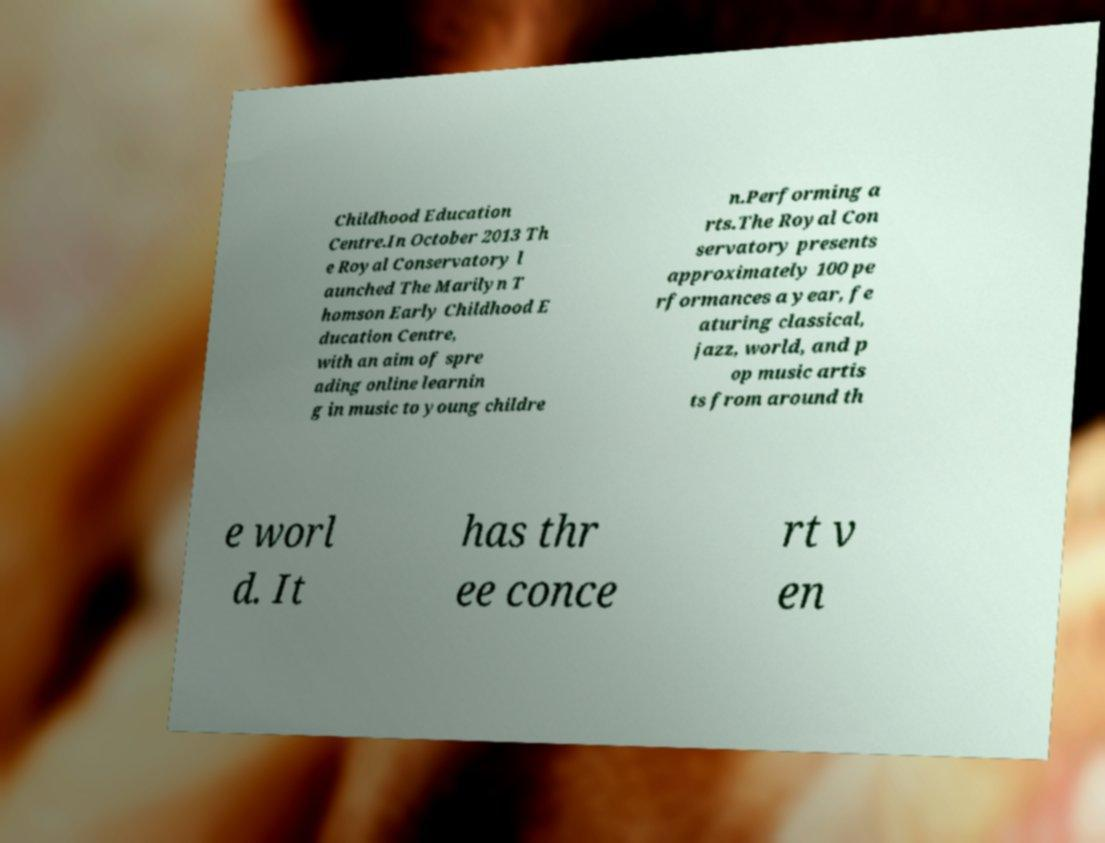There's text embedded in this image that I need extracted. Can you transcribe it verbatim? Childhood Education Centre.In October 2013 Th e Royal Conservatory l aunched The Marilyn T homson Early Childhood E ducation Centre, with an aim of spre ading online learnin g in music to young childre n.Performing a rts.The Royal Con servatory presents approximately 100 pe rformances a year, fe aturing classical, jazz, world, and p op music artis ts from around th e worl d. It has thr ee conce rt v en 